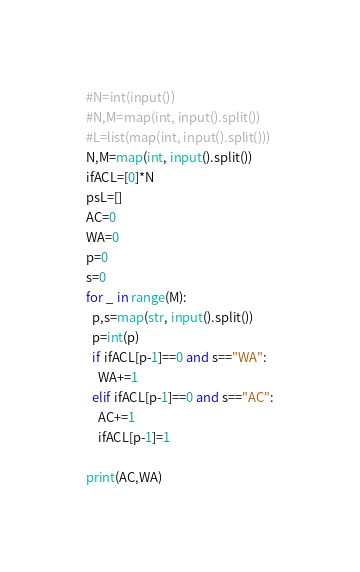<code> <loc_0><loc_0><loc_500><loc_500><_Python_>#N=int(input())
#N,M=map(int, input().split())
#L=list(map(int, input().split()))
N,M=map(int, input().split())
ifACL=[0]*N
psL=[]
AC=0
WA=0
p=0
s=0
for _ in range(M):
  p,s=map(str, input().split())
  p=int(p)
  if ifACL[p-1]==0 and s=="WA":
    WA+=1
  elif ifACL[p-1]==0 and s=="AC":
    AC+=1
    ifACL[p-1]=1

print(AC,WA)</code> 